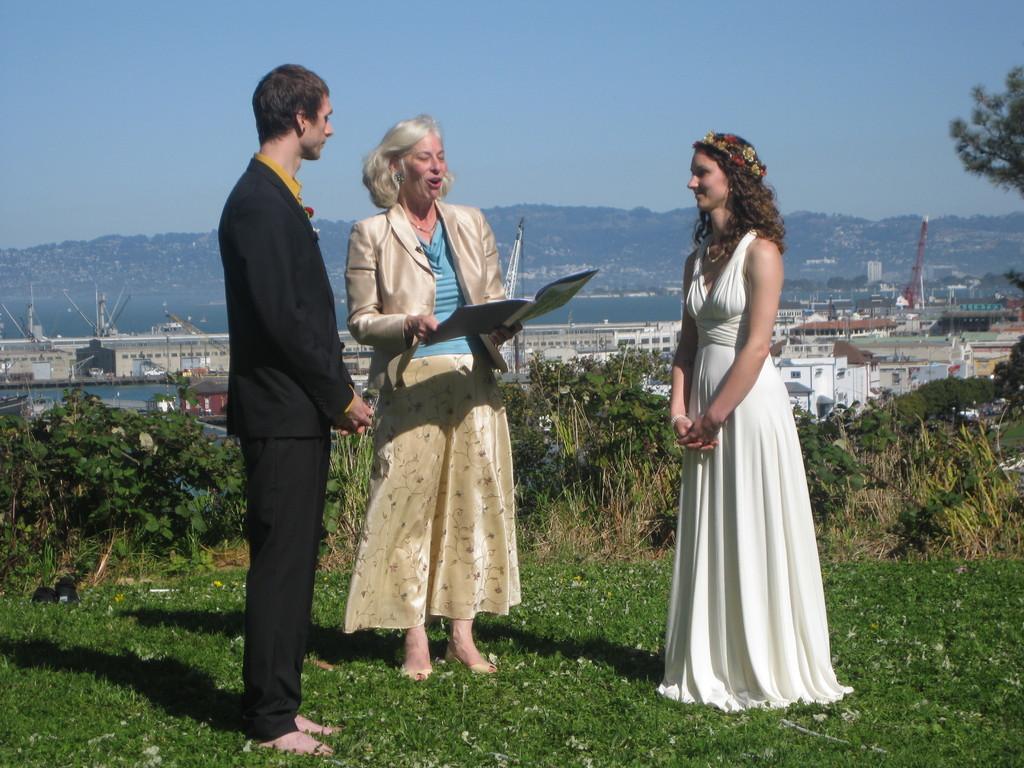How would you summarize this image in a sentence or two? In this picture we can see a bride,a groom,and an old lady. The bride is standing on the right side wearing a white gown and the groom is standing on the left side wearing a black blazer and black pant. In the centre we have an old lady reciting the vows for the wedding. They are standing on grass surrounded by beautiful scenery. 